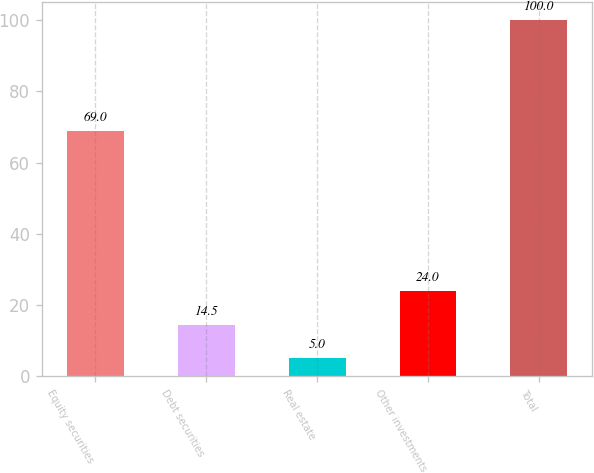Convert chart. <chart><loc_0><loc_0><loc_500><loc_500><bar_chart><fcel>Equity securities<fcel>Debt securities<fcel>Real estate<fcel>Other investments<fcel>Total<nl><fcel>69<fcel>14.5<fcel>5<fcel>24<fcel>100<nl></chart> 